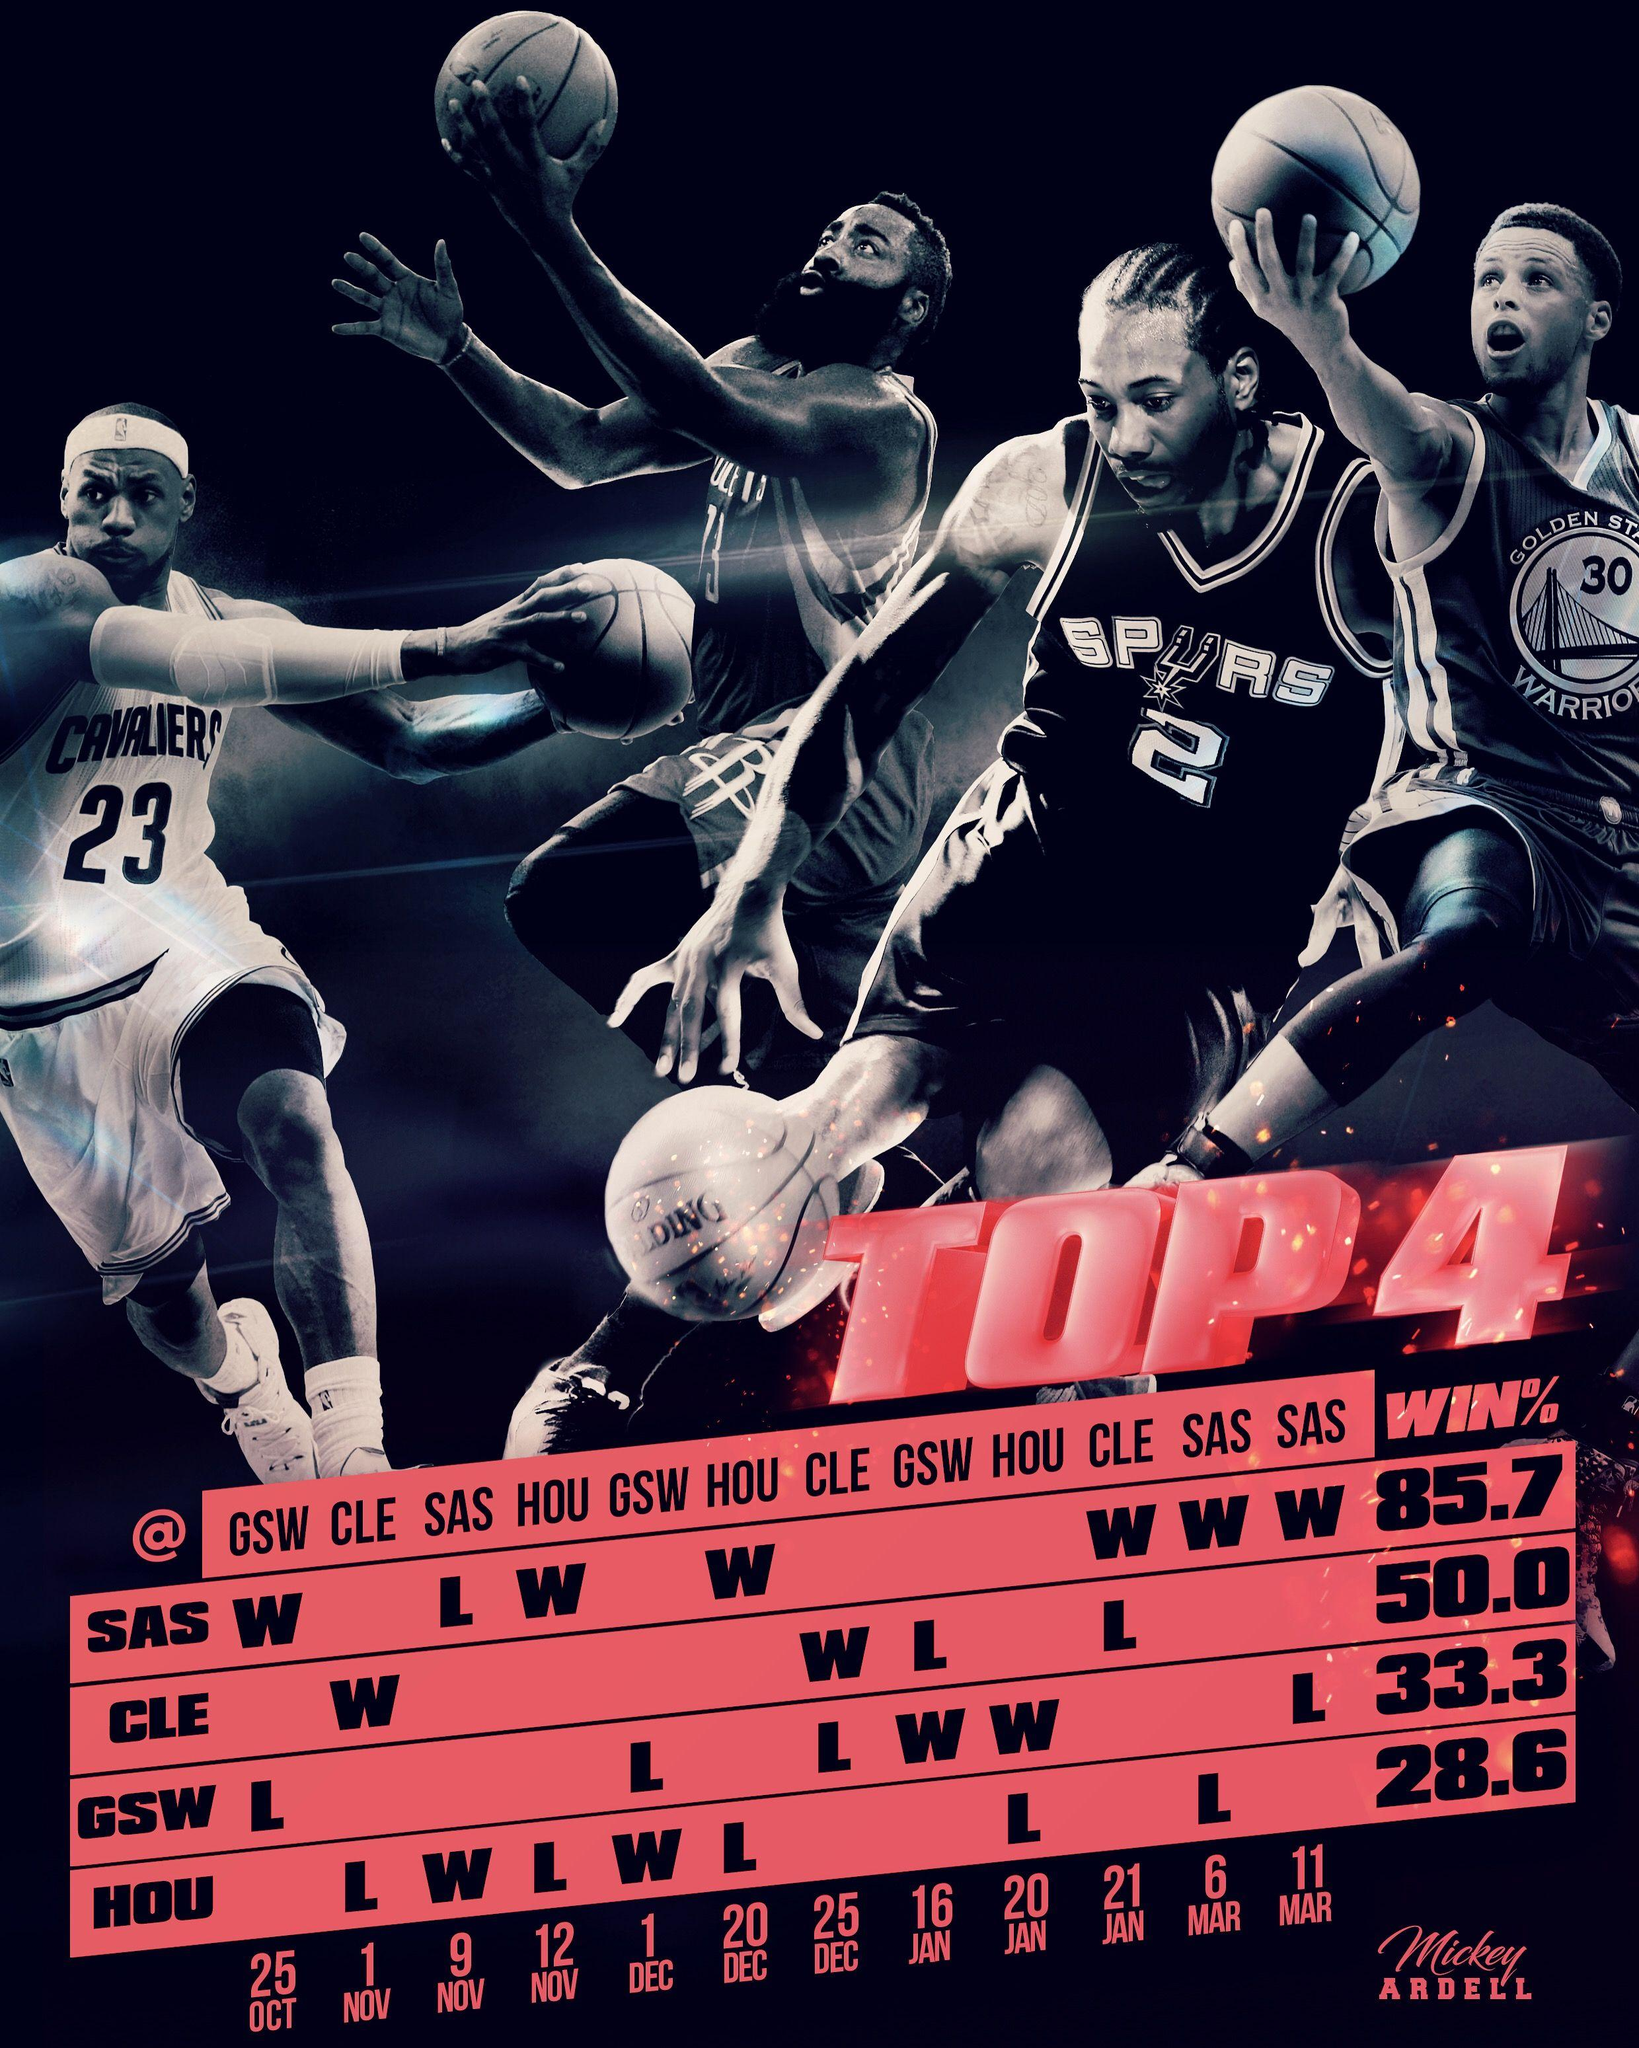Identify some key points in this picture. The team GSW won a total of 2 matches. The Houston Outlaws won the match played on December 1st. The team CLE played 4 matches. The team HOU lost in 5 matches. The match played on November 1st was won by the team CLE. 